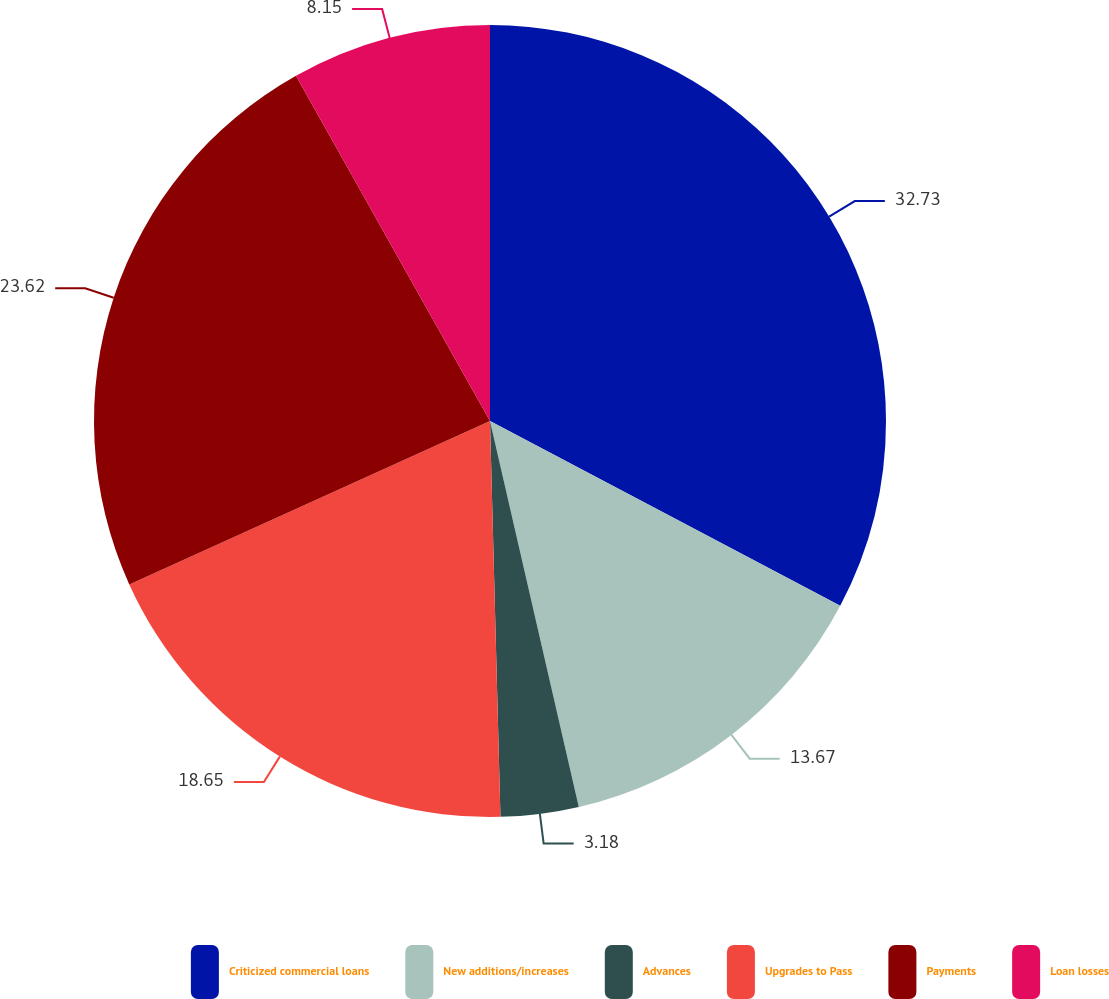<chart> <loc_0><loc_0><loc_500><loc_500><pie_chart><fcel>Criticized commercial loans<fcel>New additions/increases<fcel>Advances<fcel>Upgrades to Pass<fcel>Payments<fcel>Loan losses<nl><fcel>32.73%<fcel>13.67%<fcel>3.18%<fcel>18.65%<fcel>23.62%<fcel>8.15%<nl></chart> 